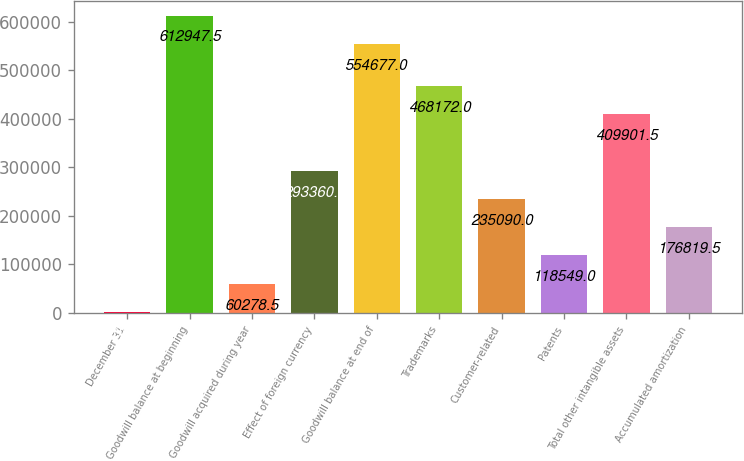Convert chart to OTSL. <chart><loc_0><loc_0><loc_500><loc_500><bar_chart><fcel>December 31<fcel>Goodwill balance at beginning<fcel>Goodwill acquired during year<fcel>Effect of foreign currency<fcel>Goodwill balance at end of<fcel>Trademarks<fcel>Customer-related<fcel>Patents<fcel>Total other intangible assets<fcel>Accumulated amortization<nl><fcel>2008<fcel>612948<fcel>60278.5<fcel>293360<fcel>554677<fcel>468172<fcel>235090<fcel>118549<fcel>409902<fcel>176820<nl></chart> 